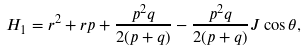Convert formula to latex. <formula><loc_0><loc_0><loc_500><loc_500>H _ { 1 } = r ^ { 2 } + r p + \frac { p ^ { 2 } q } { 2 ( p + q ) } - \frac { p ^ { 2 } q } { 2 ( p + q ) } J \cos \theta ,</formula> 